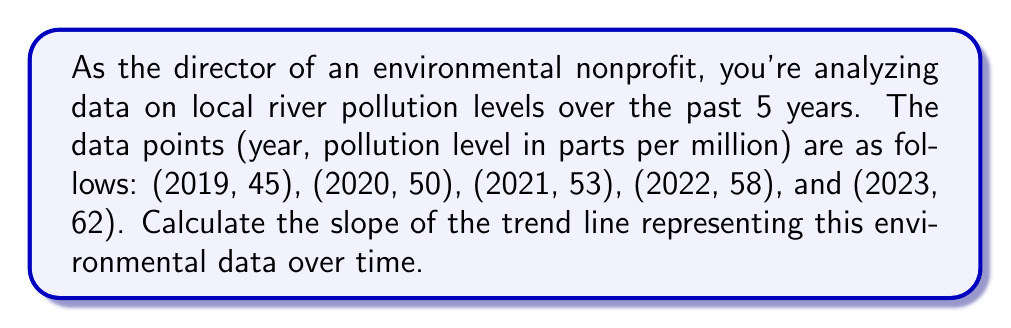Can you answer this question? To calculate the slope of the trend line, we'll use the formula for the slope of a line:

$$ m = \frac{y_2 - y_1}{x_2 - x_1} $$

Where $(x_1, y_1)$ and $(x_2, y_2)$ are two points on the line.

We'll use the first and last data points:
$(x_1, y_1) = (2019, 45)$
$(x_2, y_2) = (2023, 62)$

Plugging these into our formula:

$$ m = \frac{62 - 45}{2023 - 2019} = \frac{17}{4} $$

Simplifying:

$$ m = 4.25 $$

This means that, on average, the pollution level is increasing by 4.25 parts per million per year.
Answer: 4.25 ppm/year 